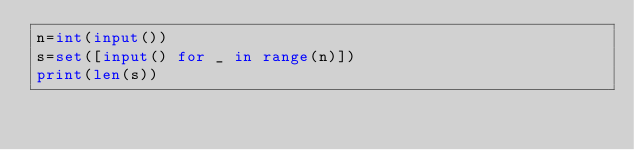Convert code to text. <code><loc_0><loc_0><loc_500><loc_500><_Python_>n=int(input())
s=set([input() for _ in range(n)])
print(len(s))</code> 